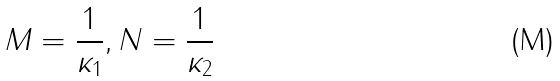<formula> <loc_0><loc_0><loc_500><loc_500>M = \frac { 1 } { \kappa _ { 1 } } , N = \frac { 1 } { \kappa _ { 2 } }</formula> 